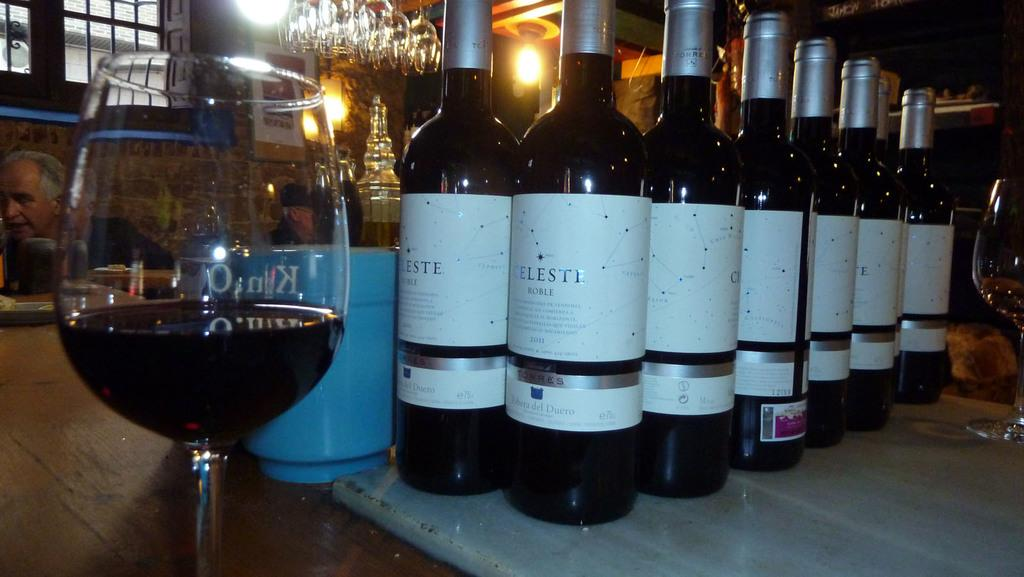Provide a one-sentence caption for the provided image. A table packed with Celesti wine bottles and glasses in a restaurant. 